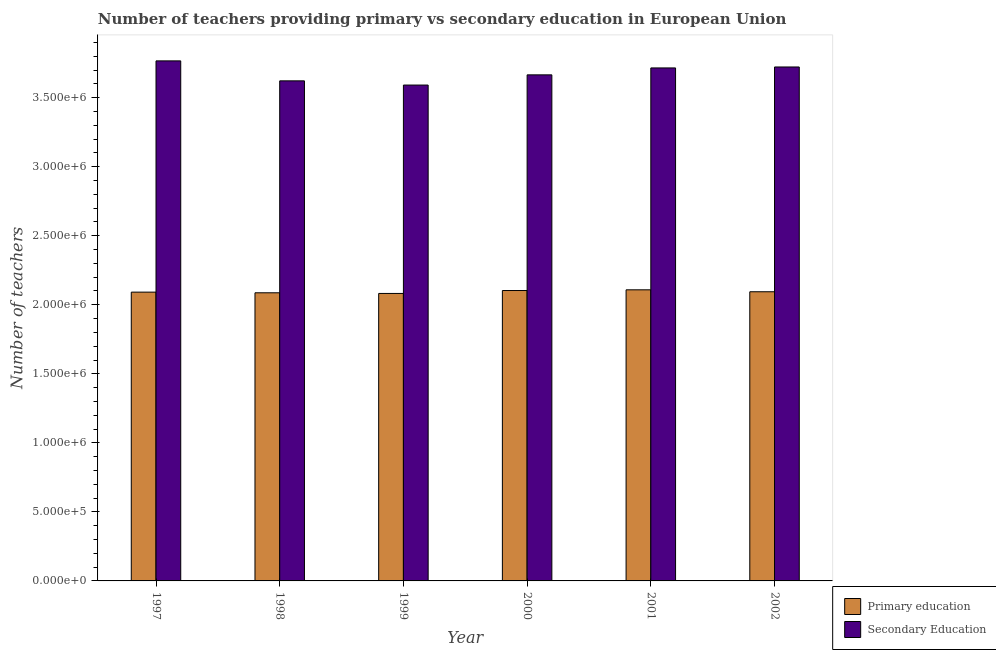How many groups of bars are there?
Your response must be concise. 6. Are the number of bars per tick equal to the number of legend labels?
Your answer should be very brief. Yes. How many bars are there on the 6th tick from the right?
Provide a succinct answer. 2. What is the label of the 4th group of bars from the left?
Provide a short and direct response. 2000. What is the number of secondary teachers in 1998?
Give a very brief answer. 3.62e+06. Across all years, what is the maximum number of secondary teachers?
Provide a succinct answer. 3.77e+06. Across all years, what is the minimum number of secondary teachers?
Give a very brief answer. 3.59e+06. What is the total number of secondary teachers in the graph?
Provide a short and direct response. 2.21e+07. What is the difference between the number of primary teachers in 1998 and that in 2001?
Give a very brief answer. -2.15e+04. What is the difference between the number of secondary teachers in 2001 and the number of primary teachers in 2000?
Ensure brevity in your answer.  5.02e+04. What is the average number of primary teachers per year?
Give a very brief answer. 2.09e+06. In the year 2001, what is the difference between the number of secondary teachers and number of primary teachers?
Your answer should be very brief. 0. What is the ratio of the number of primary teachers in 1999 to that in 2001?
Offer a terse response. 0.99. What is the difference between the highest and the second highest number of secondary teachers?
Offer a terse response. 4.41e+04. What is the difference between the highest and the lowest number of secondary teachers?
Ensure brevity in your answer.  1.75e+05. What does the 2nd bar from the left in 2000 represents?
Make the answer very short. Secondary Education. How many bars are there?
Ensure brevity in your answer.  12. Does the graph contain any zero values?
Offer a terse response. No. How many legend labels are there?
Make the answer very short. 2. What is the title of the graph?
Make the answer very short. Number of teachers providing primary vs secondary education in European Union. Does "Travel services" appear as one of the legend labels in the graph?
Give a very brief answer. No. What is the label or title of the X-axis?
Your answer should be very brief. Year. What is the label or title of the Y-axis?
Your answer should be very brief. Number of teachers. What is the Number of teachers in Primary education in 1997?
Provide a succinct answer. 2.09e+06. What is the Number of teachers in Secondary Education in 1997?
Your response must be concise. 3.77e+06. What is the Number of teachers of Primary education in 1998?
Your answer should be compact. 2.09e+06. What is the Number of teachers of Secondary Education in 1998?
Provide a succinct answer. 3.62e+06. What is the Number of teachers of Primary education in 1999?
Offer a very short reply. 2.08e+06. What is the Number of teachers in Secondary Education in 1999?
Ensure brevity in your answer.  3.59e+06. What is the Number of teachers of Primary education in 2000?
Make the answer very short. 2.10e+06. What is the Number of teachers of Secondary Education in 2000?
Offer a terse response. 3.67e+06. What is the Number of teachers in Primary education in 2001?
Ensure brevity in your answer.  2.11e+06. What is the Number of teachers of Secondary Education in 2001?
Give a very brief answer. 3.72e+06. What is the Number of teachers in Primary education in 2002?
Provide a short and direct response. 2.09e+06. What is the Number of teachers in Secondary Education in 2002?
Keep it short and to the point. 3.72e+06. Across all years, what is the maximum Number of teachers of Primary education?
Offer a very short reply. 2.11e+06. Across all years, what is the maximum Number of teachers of Secondary Education?
Provide a short and direct response. 3.77e+06. Across all years, what is the minimum Number of teachers of Primary education?
Your response must be concise. 2.08e+06. Across all years, what is the minimum Number of teachers of Secondary Education?
Provide a succinct answer. 3.59e+06. What is the total Number of teachers of Primary education in the graph?
Your answer should be very brief. 1.26e+07. What is the total Number of teachers in Secondary Education in the graph?
Make the answer very short. 2.21e+07. What is the difference between the Number of teachers of Primary education in 1997 and that in 1998?
Your response must be concise. 4759.62. What is the difference between the Number of teachers of Secondary Education in 1997 and that in 1998?
Provide a short and direct response. 1.45e+05. What is the difference between the Number of teachers of Primary education in 1997 and that in 1999?
Give a very brief answer. 9567. What is the difference between the Number of teachers in Secondary Education in 1997 and that in 1999?
Provide a succinct answer. 1.75e+05. What is the difference between the Number of teachers in Primary education in 1997 and that in 2000?
Your answer should be very brief. -1.17e+04. What is the difference between the Number of teachers of Secondary Education in 1997 and that in 2000?
Give a very brief answer. 1.01e+05. What is the difference between the Number of teachers of Primary education in 1997 and that in 2001?
Ensure brevity in your answer.  -1.68e+04. What is the difference between the Number of teachers of Secondary Education in 1997 and that in 2001?
Ensure brevity in your answer.  5.10e+04. What is the difference between the Number of teachers of Primary education in 1997 and that in 2002?
Give a very brief answer. -2694.62. What is the difference between the Number of teachers of Secondary Education in 1997 and that in 2002?
Offer a terse response. 4.41e+04. What is the difference between the Number of teachers of Primary education in 1998 and that in 1999?
Offer a very short reply. 4807.38. What is the difference between the Number of teachers in Secondary Education in 1998 and that in 1999?
Offer a very short reply. 3.05e+04. What is the difference between the Number of teachers of Primary education in 1998 and that in 2000?
Your answer should be very brief. -1.64e+04. What is the difference between the Number of teachers in Secondary Education in 1998 and that in 2000?
Your response must be concise. -4.34e+04. What is the difference between the Number of teachers in Primary education in 1998 and that in 2001?
Keep it short and to the point. -2.15e+04. What is the difference between the Number of teachers of Secondary Education in 1998 and that in 2001?
Your answer should be very brief. -9.36e+04. What is the difference between the Number of teachers in Primary education in 1998 and that in 2002?
Keep it short and to the point. -7454.25. What is the difference between the Number of teachers of Secondary Education in 1998 and that in 2002?
Keep it short and to the point. -1.00e+05. What is the difference between the Number of teachers in Primary education in 1999 and that in 2000?
Make the answer very short. -2.13e+04. What is the difference between the Number of teachers of Secondary Education in 1999 and that in 2000?
Give a very brief answer. -7.39e+04. What is the difference between the Number of teachers of Primary education in 1999 and that in 2001?
Provide a short and direct response. -2.63e+04. What is the difference between the Number of teachers in Secondary Education in 1999 and that in 2001?
Your answer should be very brief. -1.24e+05. What is the difference between the Number of teachers of Primary education in 1999 and that in 2002?
Give a very brief answer. -1.23e+04. What is the difference between the Number of teachers in Secondary Education in 1999 and that in 2002?
Keep it short and to the point. -1.31e+05. What is the difference between the Number of teachers in Primary education in 2000 and that in 2001?
Offer a terse response. -5092.25. What is the difference between the Number of teachers in Secondary Education in 2000 and that in 2001?
Provide a succinct answer. -5.02e+04. What is the difference between the Number of teachers in Primary education in 2000 and that in 2002?
Provide a succinct answer. 8995. What is the difference between the Number of teachers in Secondary Education in 2000 and that in 2002?
Your answer should be compact. -5.71e+04. What is the difference between the Number of teachers of Primary education in 2001 and that in 2002?
Provide a succinct answer. 1.41e+04. What is the difference between the Number of teachers of Secondary Education in 2001 and that in 2002?
Give a very brief answer. -6899.25. What is the difference between the Number of teachers of Primary education in 1997 and the Number of teachers of Secondary Education in 1998?
Give a very brief answer. -1.53e+06. What is the difference between the Number of teachers in Primary education in 1997 and the Number of teachers in Secondary Education in 1999?
Provide a short and direct response. -1.50e+06. What is the difference between the Number of teachers in Primary education in 1997 and the Number of teachers in Secondary Education in 2000?
Your answer should be compact. -1.57e+06. What is the difference between the Number of teachers of Primary education in 1997 and the Number of teachers of Secondary Education in 2001?
Keep it short and to the point. -1.62e+06. What is the difference between the Number of teachers in Primary education in 1997 and the Number of teachers in Secondary Education in 2002?
Your answer should be compact. -1.63e+06. What is the difference between the Number of teachers of Primary education in 1998 and the Number of teachers of Secondary Education in 1999?
Your response must be concise. -1.50e+06. What is the difference between the Number of teachers in Primary education in 1998 and the Number of teachers in Secondary Education in 2000?
Your answer should be very brief. -1.58e+06. What is the difference between the Number of teachers in Primary education in 1998 and the Number of teachers in Secondary Education in 2001?
Your answer should be compact. -1.63e+06. What is the difference between the Number of teachers in Primary education in 1998 and the Number of teachers in Secondary Education in 2002?
Ensure brevity in your answer.  -1.64e+06. What is the difference between the Number of teachers of Primary education in 1999 and the Number of teachers of Secondary Education in 2000?
Ensure brevity in your answer.  -1.58e+06. What is the difference between the Number of teachers in Primary education in 1999 and the Number of teachers in Secondary Education in 2001?
Give a very brief answer. -1.63e+06. What is the difference between the Number of teachers of Primary education in 1999 and the Number of teachers of Secondary Education in 2002?
Offer a terse response. -1.64e+06. What is the difference between the Number of teachers in Primary education in 2000 and the Number of teachers in Secondary Education in 2001?
Offer a very short reply. -1.61e+06. What is the difference between the Number of teachers of Primary education in 2000 and the Number of teachers of Secondary Education in 2002?
Offer a terse response. -1.62e+06. What is the difference between the Number of teachers in Primary education in 2001 and the Number of teachers in Secondary Education in 2002?
Your answer should be very brief. -1.61e+06. What is the average Number of teachers in Primary education per year?
Your answer should be compact. 2.09e+06. What is the average Number of teachers of Secondary Education per year?
Make the answer very short. 3.68e+06. In the year 1997, what is the difference between the Number of teachers of Primary education and Number of teachers of Secondary Education?
Provide a succinct answer. -1.67e+06. In the year 1998, what is the difference between the Number of teachers in Primary education and Number of teachers in Secondary Education?
Make the answer very short. -1.54e+06. In the year 1999, what is the difference between the Number of teachers of Primary education and Number of teachers of Secondary Education?
Offer a terse response. -1.51e+06. In the year 2000, what is the difference between the Number of teachers of Primary education and Number of teachers of Secondary Education?
Your response must be concise. -1.56e+06. In the year 2001, what is the difference between the Number of teachers of Primary education and Number of teachers of Secondary Education?
Keep it short and to the point. -1.61e+06. In the year 2002, what is the difference between the Number of teachers of Primary education and Number of teachers of Secondary Education?
Provide a succinct answer. -1.63e+06. What is the ratio of the Number of teachers in Primary education in 1997 to that in 1998?
Your answer should be very brief. 1. What is the ratio of the Number of teachers in Secondary Education in 1997 to that in 1998?
Offer a very short reply. 1.04. What is the ratio of the Number of teachers in Secondary Education in 1997 to that in 1999?
Your answer should be very brief. 1.05. What is the ratio of the Number of teachers in Secondary Education in 1997 to that in 2000?
Your response must be concise. 1.03. What is the ratio of the Number of teachers of Secondary Education in 1997 to that in 2001?
Offer a terse response. 1.01. What is the ratio of the Number of teachers in Secondary Education in 1997 to that in 2002?
Keep it short and to the point. 1.01. What is the ratio of the Number of teachers of Primary education in 1998 to that in 1999?
Your answer should be compact. 1. What is the ratio of the Number of teachers of Secondary Education in 1998 to that in 1999?
Keep it short and to the point. 1.01. What is the ratio of the Number of teachers in Primary education in 1998 to that in 2000?
Ensure brevity in your answer.  0.99. What is the ratio of the Number of teachers in Secondary Education in 1998 to that in 2001?
Make the answer very short. 0.97. What is the ratio of the Number of teachers of Primary education in 1998 to that in 2002?
Provide a succinct answer. 1. What is the ratio of the Number of teachers of Primary education in 1999 to that in 2000?
Offer a terse response. 0.99. What is the ratio of the Number of teachers in Secondary Education in 1999 to that in 2000?
Your answer should be very brief. 0.98. What is the ratio of the Number of teachers in Primary education in 1999 to that in 2001?
Provide a short and direct response. 0.99. What is the ratio of the Number of teachers of Secondary Education in 1999 to that in 2001?
Your answer should be compact. 0.97. What is the ratio of the Number of teachers in Primary education in 1999 to that in 2002?
Ensure brevity in your answer.  0.99. What is the ratio of the Number of teachers in Secondary Education in 1999 to that in 2002?
Ensure brevity in your answer.  0.96. What is the ratio of the Number of teachers of Secondary Education in 2000 to that in 2001?
Your answer should be compact. 0.99. What is the ratio of the Number of teachers of Secondary Education in 2000 to that in 2002?
Keep it short and to the point. 0.98. What is the difference between the highest and the second highest Number of teachers of Primary education?
Ensure brevity in your answer.  5092.25. What is the difference between the highest and the second highest Number of teachers of Secondary Education?
Keep it short and to the point. 4.41e+04. What is the difference between the highest and the lowest Number of teachers in Primary education?
Give a very brief answer. 2.63e+04. What is the difference between the highest and the lowest Number of teachers in Secondary Education?
Your response must be concise. 1.75e+05. 